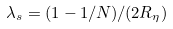<formula> <loc_0><loc_0><loc_500><loc_500>\lambda _ { s } = ( 1 - 1 / N ) / ( 2 R _ { \eta } )</formula> 